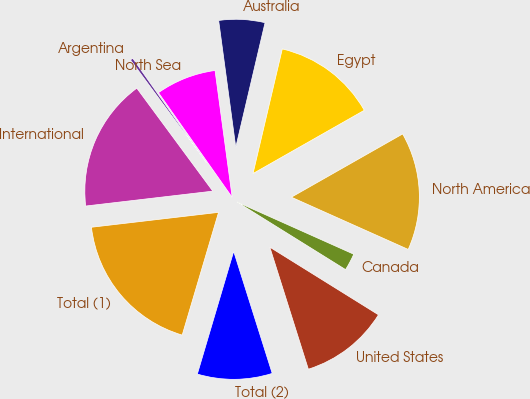Convert chart. <chart><loc_0><loc_0><loc_500><loc_500><pie_chart><fcel>United States<fcel>Canada<fcel>North America<fcel>Egypt<fcel>Australia<fcel>North Sea<fcel>Argentina<fcel>International<fcel>Total (1)<fcel>Total (2)<nl><fcel>11.27%<fcel>2.17%<fcel>14.92%<fcel>13.1%<fcel>5.81%<fcel>7.63%<fcel>0.35%<fcel>16.74%<fcel>18.56%<fcel>9.45%<nl></chart> 